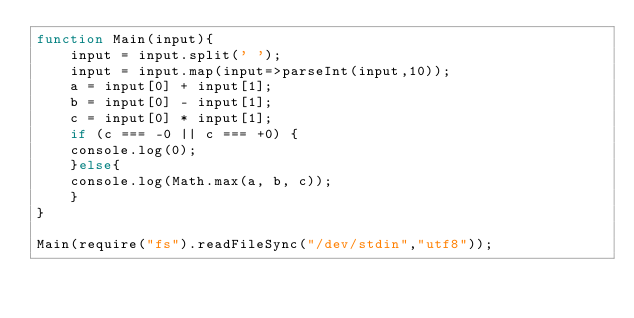Convert code to text. <code><loc_0><loc_0><loc_500><loc_500><_JavaScript_>function Main(input){
	input = input.split(' ');
    input = input.map(input=>parseInt(input,10));
    a = input[0] + input[1];
    b = input[0] - input[1];
    c = input[0] * input[1];
    if (c === -0 || c === +0) {
    console.log(0);
    }else{
    console.log(Math.max(a, b, c));
    }  
}
 
Main(require("fs").readFileSync("/dev/stdin","utf8"));</code> 